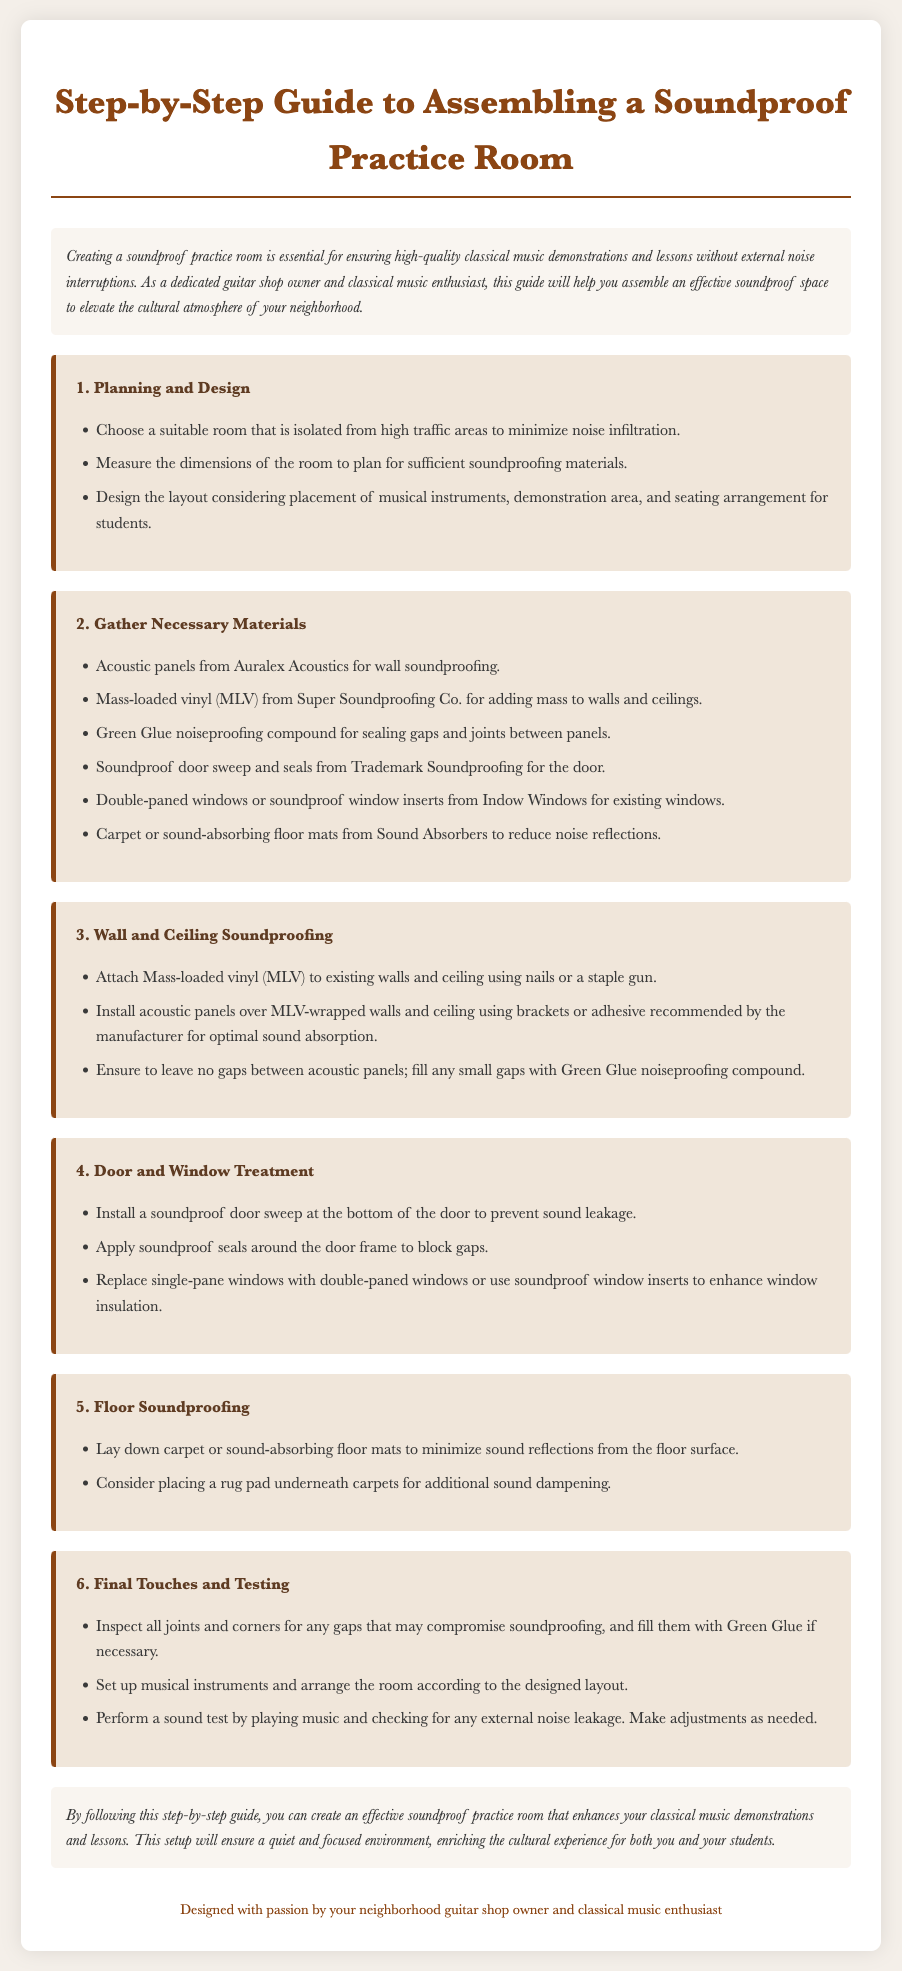What is the first step outlined in the guide? The first step to assembling the soundproof practice room is the initiation of planning and design.
Answer: Planning and Design How many materials are listed for soundproofing? The document lists six necessary materials for soundproofing the practice room.
Answer: Six What compound is recommended for sealing gaps? The guide suggests using Green Glue for sealing gaps and joints between panels.
Answer: Green Glue What is the purpose of the soundproof door sweep? The soundproof door sweep is intended to prevent sound leakage at the bottom of the door.
Answer: Prevent sound leakage What should you do after inspecting all joints and corners? After inspecting, you should fill any gaps determined to compromise soundproofing with Green Glue if necessary.
Answer: Fill gaps with Green Glue Which brand is recommended for acoustic panels? Auralex Acoustics is the recommended brand for acoustic panels in the guide.
Answer: Auralex Acoustics What flooring option is suggested to minimize sound reflections? The guide suggests laying down carpet or sound-absorbing floor mats to minimize sound reflections.
Answer: Carpet or sound-absorbing floor mats After completing the assembly, what is the final testing activity suggested? The final testing activity involves performing a sound test by playing music to check for noise leakage.
Answer: Sound test by playing music 